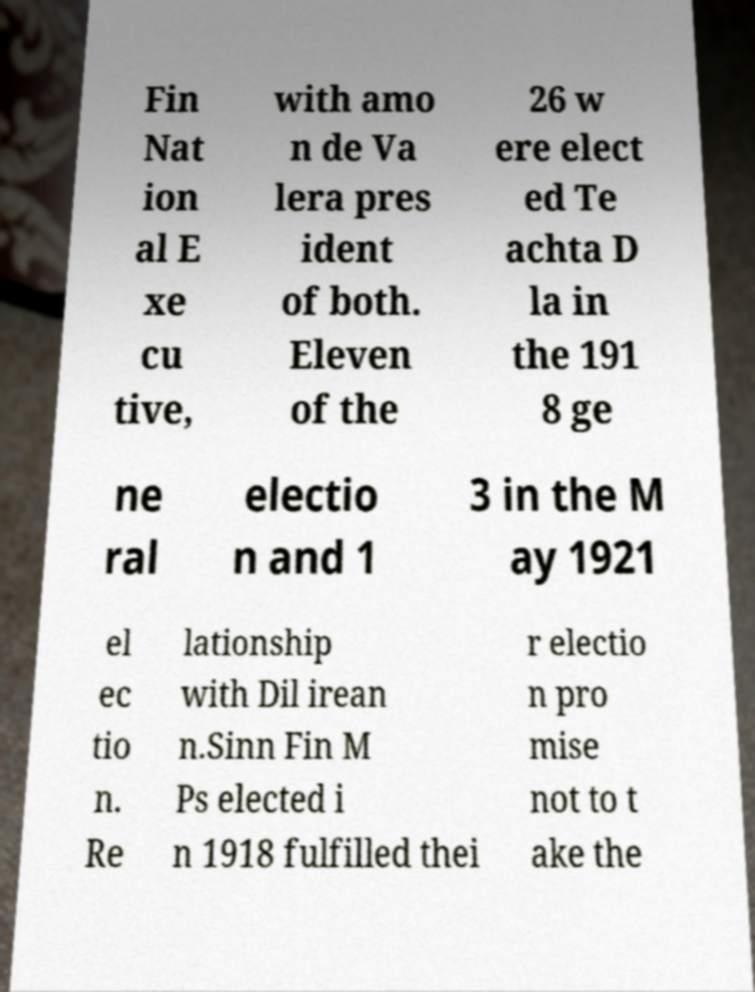What messages or text are displayed in this image? I need them in a readable, typed format. Fin Nat ion al E xe cu tive, with amo n de Va lera pres ident of both. Eleven of the 26 w ere elect ed Te achta D la in the 191 8 ge ne ral electio n and 1 3 in the M ay 1921 el ec tio n. Re lationship with Dil irean n.Sinn Fin M Ps elected i n 1918 fulfilled thei r electio n pro mise not to t ake the 